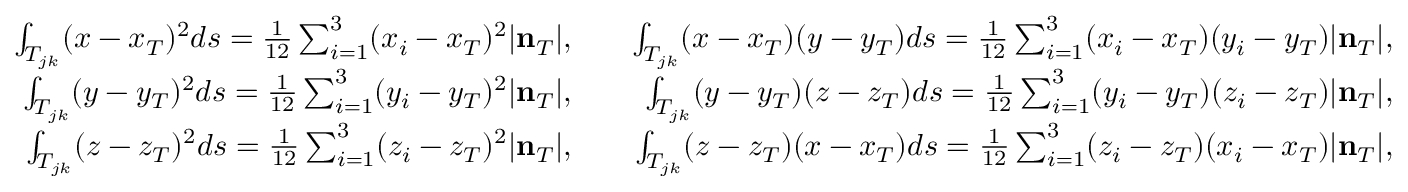<formula> <loc_0><loc_0><loc_500><loc_500>\begin{array} { r l r } { \int _ { T _ { j k } } ( x - x _ { T } ) ^ { 2 } d s = \frac { 1 } { 1 2 } \sum _ { i = 1 } ^ { 3 } ( x _ { i } - x _ { T } ) ^ { 2 } | { n } _ { T } | , } & { \int _ { T _ { j k } } ( x - x _ { T } ) ( y - y _ { T } ) d s = \frac { 1 } { 1 2 } \sum _ { i = 1 } ^ { 3 } ( x _ { i } - x _ { T } ) ( y _ { i } - y _ { T } ) | { n } _ { T } | , } \\ { \int _ { T _ { j k } } ( y - y _ { T } ) ^ { 2 } d s = \frac { 1 } { 1 2 } \sum _ { i = 1 } ^ { 3 } ( y _ { i } - y _ { T } ) ^ { 2 } | { n } _ { T } | , } & { \int _ { T _ { j k } } ( y - y _ { T } ) ( z - z _ { T } ) d s = \frac { 1 } { 1 2 } \sum _ { i = 1 } ^ { 3 } ( y _ { i } - y _ { T } ) ( z _ { i } - z _ { T } ) | { n } _ { T } | , } \\ { \int _ { T _ { j k } } ( z - z _ { T } ) ^ { 2 } d s = \frac { 1 } { 1 2 } \sum _ { i = 1 } ^ { 3 } ( z _ { i } - z _ { T } ) ^ { 2 } | { n } _ { T } | , } & { \int _ { T _ { j k } } ( z - z _ { T } ) ( x - x _ { T } ) d s = \frac { 1 } { 1 2 } \sum _ { i = 1 } ^ { 3 } ( z _ { i } - z _ { T } ) ( x _ { i } - x _ { T } ) | { n } _ { T } | , } \end{array}</formula> 